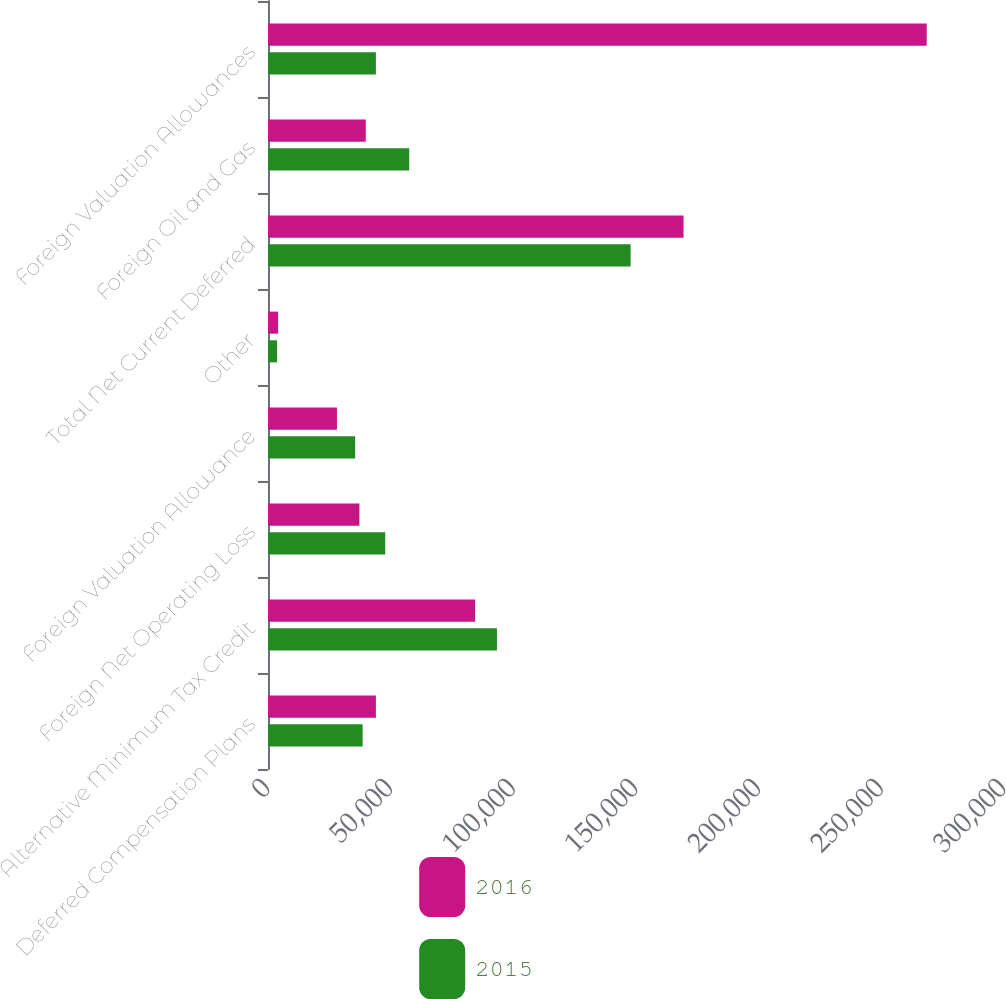Convert chart to OTSL. <chart><loc_0><loc_0><loc_500><loc_500><stacked_bar_chart><ecel><fcel>Deferred Compensation Plans<fcel>Alternative Minimum Tax Credit<fcel>Foreign Net Operating Loss<fcel>Foreign Valuation Allowance<fcel>Other<fcel>Total Net Current Deferred<fcel>Foreign Oil and Gas<fcel>Foreign Valuation Allowances<nl><fcel>2016<fcel>43984<fcel>84426<fcel>37251<fcel>28097<fcel>4137<fcel>169387<fcel>39852<fcel>268499<nl><fcel>2015<fcel>38559<fcel>93316<fcel>47786<fcel>35536<fcel>3687<fcel>147812<fcel>57569<fcel>43984<nl></chart> 